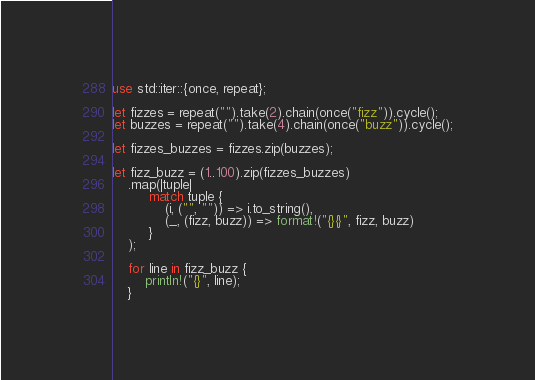<code> <loc_0><loc_0><loc_500><loc_500><_Rust_>use std::iter::{once, repeat};

let fizzes = repeat("").take(2).chain(once("fizz")).cycle();
let buzzes = repeat("").take(4).chain(once("buzz")).cycle();

let fizzes_buzzes = fizzes.zip(buzzes);

let fizz_buzz = (1..100).zip(fizzes_buzzes)
    .map(|tuple|
         match tuple {
             (i, ("", "")) => i.to_string(),
             (_, (fizz, buzz)) => format!("{}{}", fizz, buzz)
         }
    );

    for line in fizz_buzz {
        println!("{}", line);
    }
</code> 